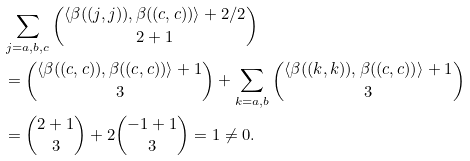<formula> <loc_0><loc_0><loc_500><loc_500>& \sum _ { j = a , b , c } \binom { \langle \beta ( ( j , j ) ) , \beta ( ( c , c ) ) \rangle + 2 / 2 } { 2 + 1 } \\ & = \binom { \langle \beta ( ( c , c ) ) , \beta ( ( c , c ) ) \rangle + 1 } { 3 } + \sum _ { k = a , b } \binom { \langle \beta ( ( k , k ) ) , \beta ( ( c , c ) ) \rangle + 1 } { 3 } \\ & = \binom { 2 + 1 } { 3 } + 2 \binom { - 1 + 1 } { 3 } = 1 \neq 0 .</formula> 